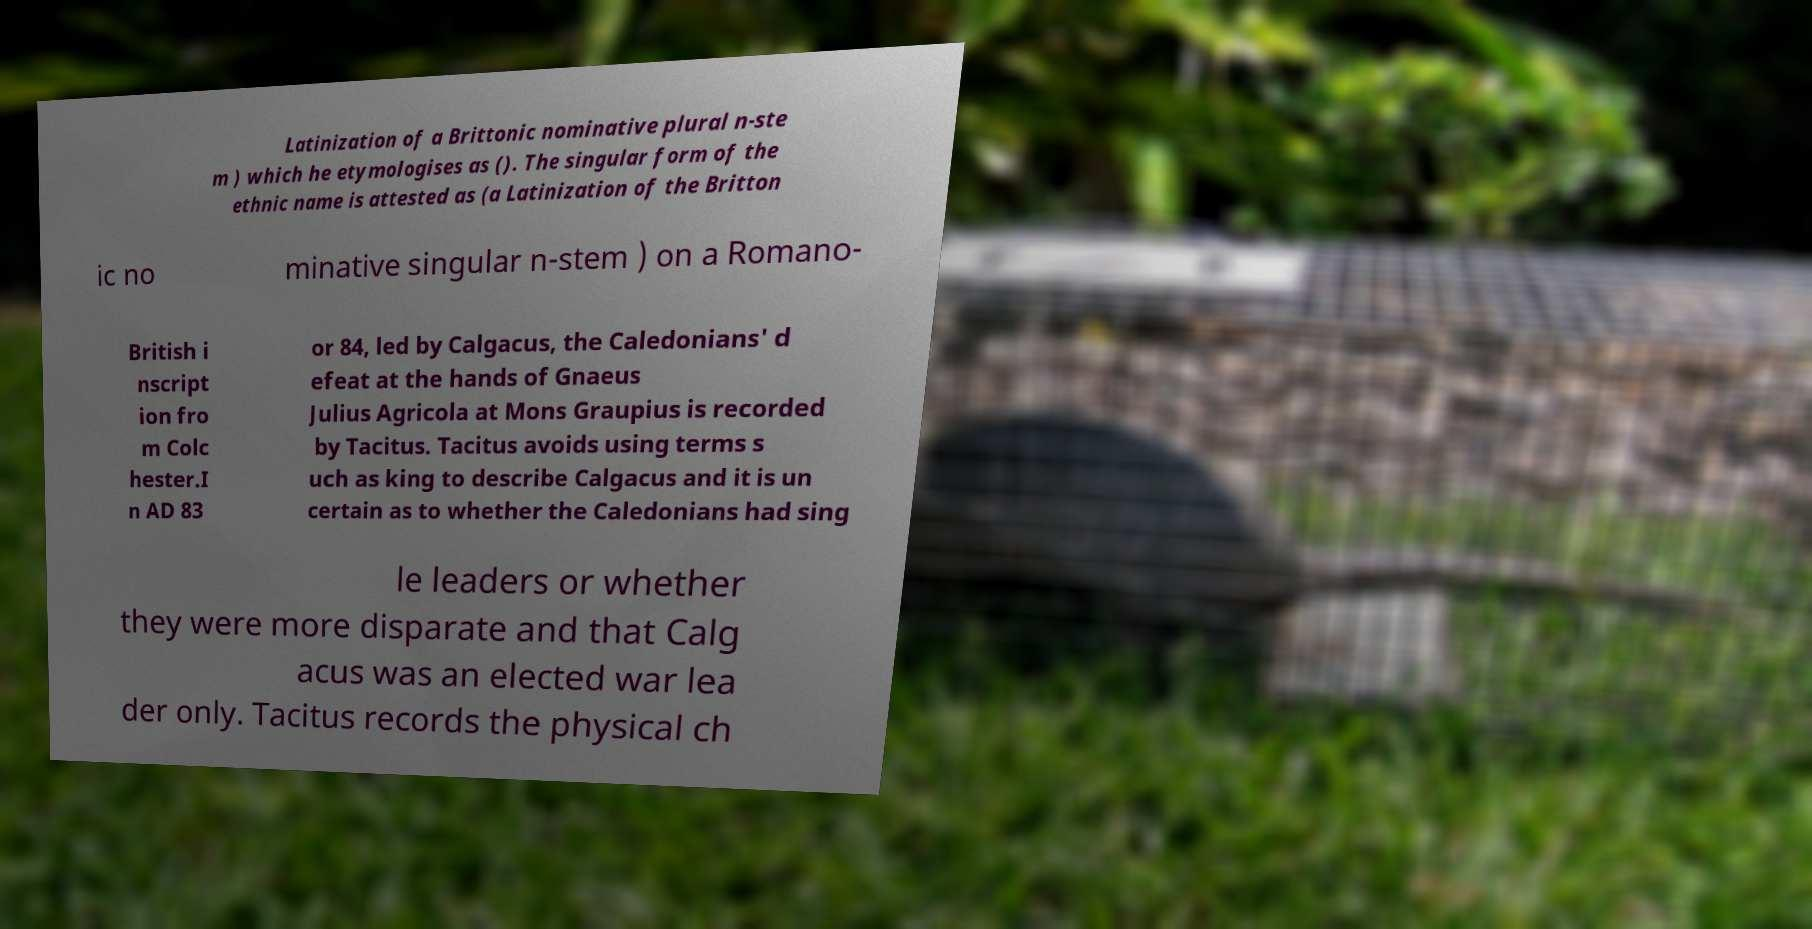For documentation purposes, I need the text within this image transcribed. Could you provide that? Latinization of a Brittonic nominative plural n-ste m ) which he etymologises as (). The singular form of the ethnic name is attested as (a Latinization of the Britton ic no minative singular n-stem ) on a Romano- British i nscript ion fro m Colc hester.I n AD 83 or 84, led by Calgacus, the Caledonians' d efeat at the hands of Gnaeus Julius Agricola at Mons Graupius is recorded by Tacitus. Tacitus avoids using terms s uch as king to describe Calgacus and it is un certain as to whether the Caledonians had sing le leaders or whether they were more disparate and that Calg acus was an elected war lea der only. Tacitus records the physical ch 